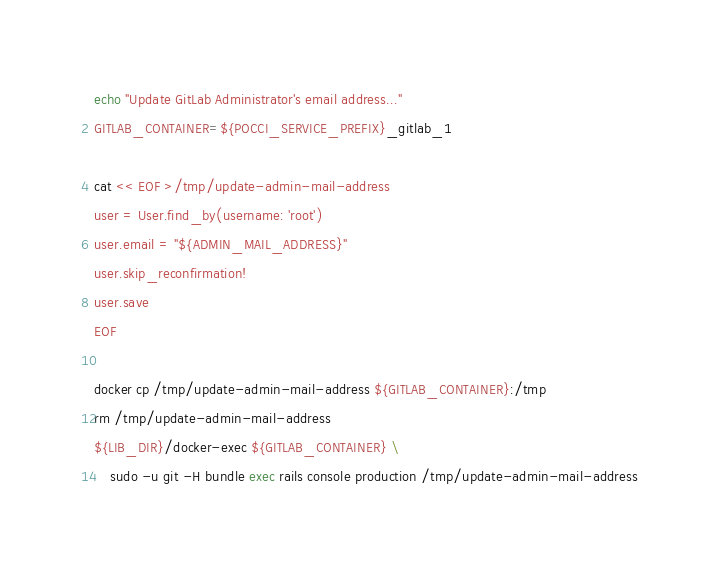Convert code to text. <code><loc_0><loc_0><loc_500><loc_500><_Bash_>echo "Update GitLab Administrator's email address..."
GITLAB_CONTAINER=${POCCI_SERVICE_PREFIX}_gitlab_1

cat << EOF >/tmp/update-admin-mail-address
user = User.find_by(username: 'root')
user.email = "${ADMIN_MAIL_ADDRESS}"
user.skip_reconfirmation!
user.save
EOF

docker cp /tmp/update-admin-mail-address ${GITLAB_CONTAINER}:/tmp
rm /tmp/update-admin-mail-address
${LIB_DIR}/docker-exec ${GITLAB_CONTAINER} \
    sudo -u git -H bundle exec rails console production /tmp/update-admin-mail-address
</code> 